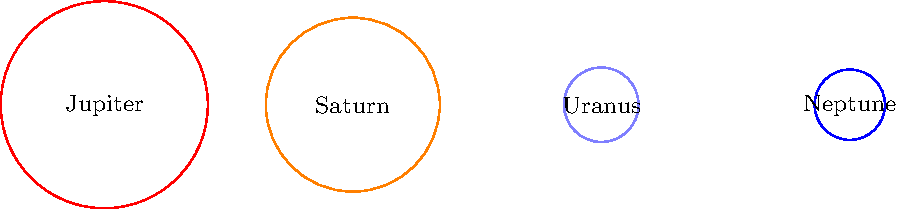In the diagram above, the sizes of the gas giants in our solar system are represented by scaled circles. If the radius of Jupiter's circle is 5 units, what is the approximate radius of Neptune's circle? To solve this problem, we need to follow these steps:

1. Understand the scale: Jupiter's circle has a radius of 5 units.
2. Observe the relative sizes: Neptune appears to be the smallest circle.
3. Compare Neptune to Jupiter: Neptune's circle looks about 1/3 the size of Jupiter's.
4. Calculate the approximate radius:
   $$\text{Neptune's radius} \approx \frac{1}{3} \times \text{Jupiter's radius}$$
   $$\text{Neptune's radius} \approx \frac{1}{3} \times 5 \text{ units}$$
   $$\text{Neptune's radius} \approx 1.67 \text{ units}$$
5. Round to the nearest tenth:
   $$\text{Neptune's radius} \approx 1.7 \text{ units}$$

This approximation aligns with the actual relative sizes of Jupiter and Neptune in our solar system, where Neptune's radius is about 3.88 times smaller than Jupiter's.
Answer: 1.7 units 